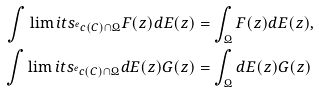Convert formula to latex. <formula><loc_0><loc_0><loc_500><loc_500>\int \lim i t s _ { ^ { e } c ( C ) \cap \Omega } F ( z ) d E ( z ) & = \int _ { \Omega } F ( z ) d E ( z ) , \\ \int \lim i t s _ { ^ { e } c ( C ) \cap \Omega } d E ( z ) G ( z ) & = \int _ { \Omega } d E ( z ) G ( z )</formula> 